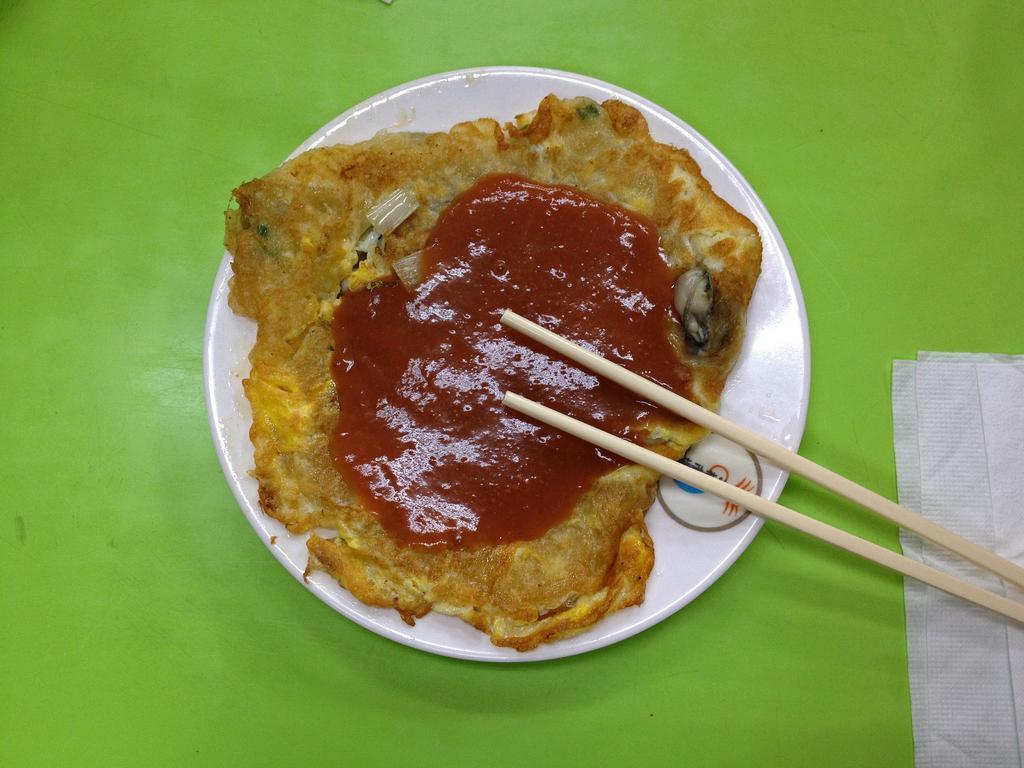Can you describe this image briefly? In this picture there is a plate on the table at the center of the image and it contains food in it. 